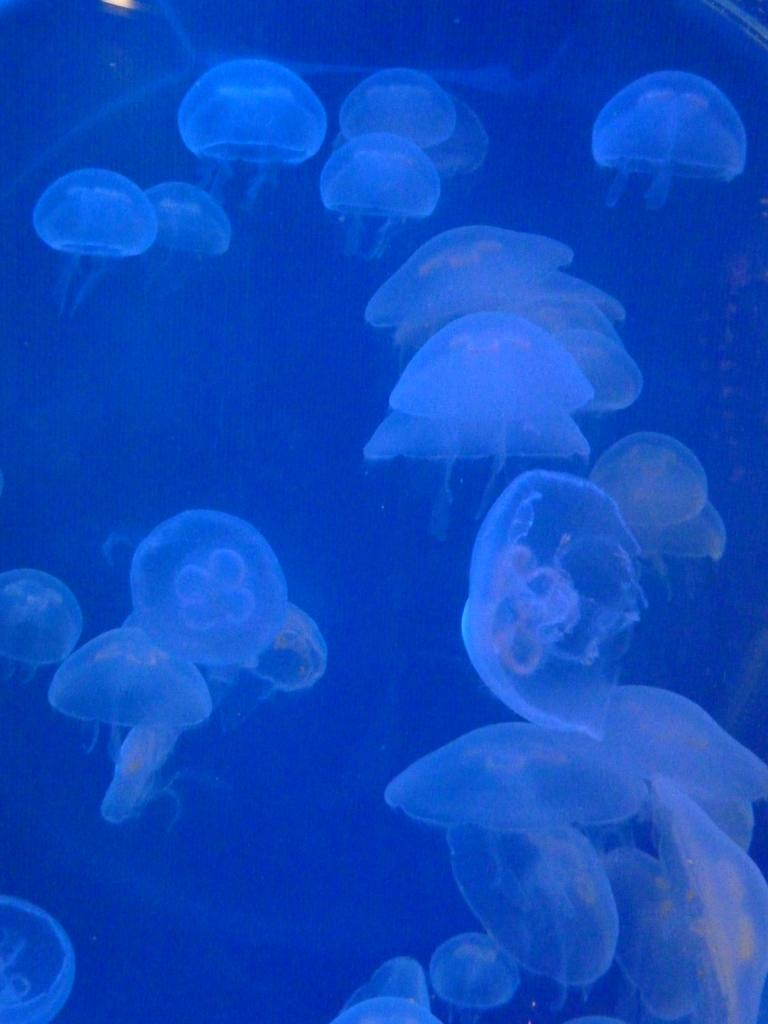What type of sea creatures are in the image? There are jellyfish in the image. Where are the jellyfish located? The jellyfish are in water. How many pins are holding the bushes in place in the image? There are no bushes or pins present in the image; it features jellyfish in water. 